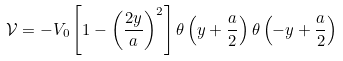<formula> <loc_0><loc_0><loc_500><loc_500>\mathcal { V } = - V _ { 0 } \left [ 1 - \left ( \frac { 2 y } { a } \right ) ^ { 2 } \right ] \theta \left ( y + \frac { a } { 2 } \right ) \theta \left ( - y + \frac { a } { 2 } \right )</formula> 